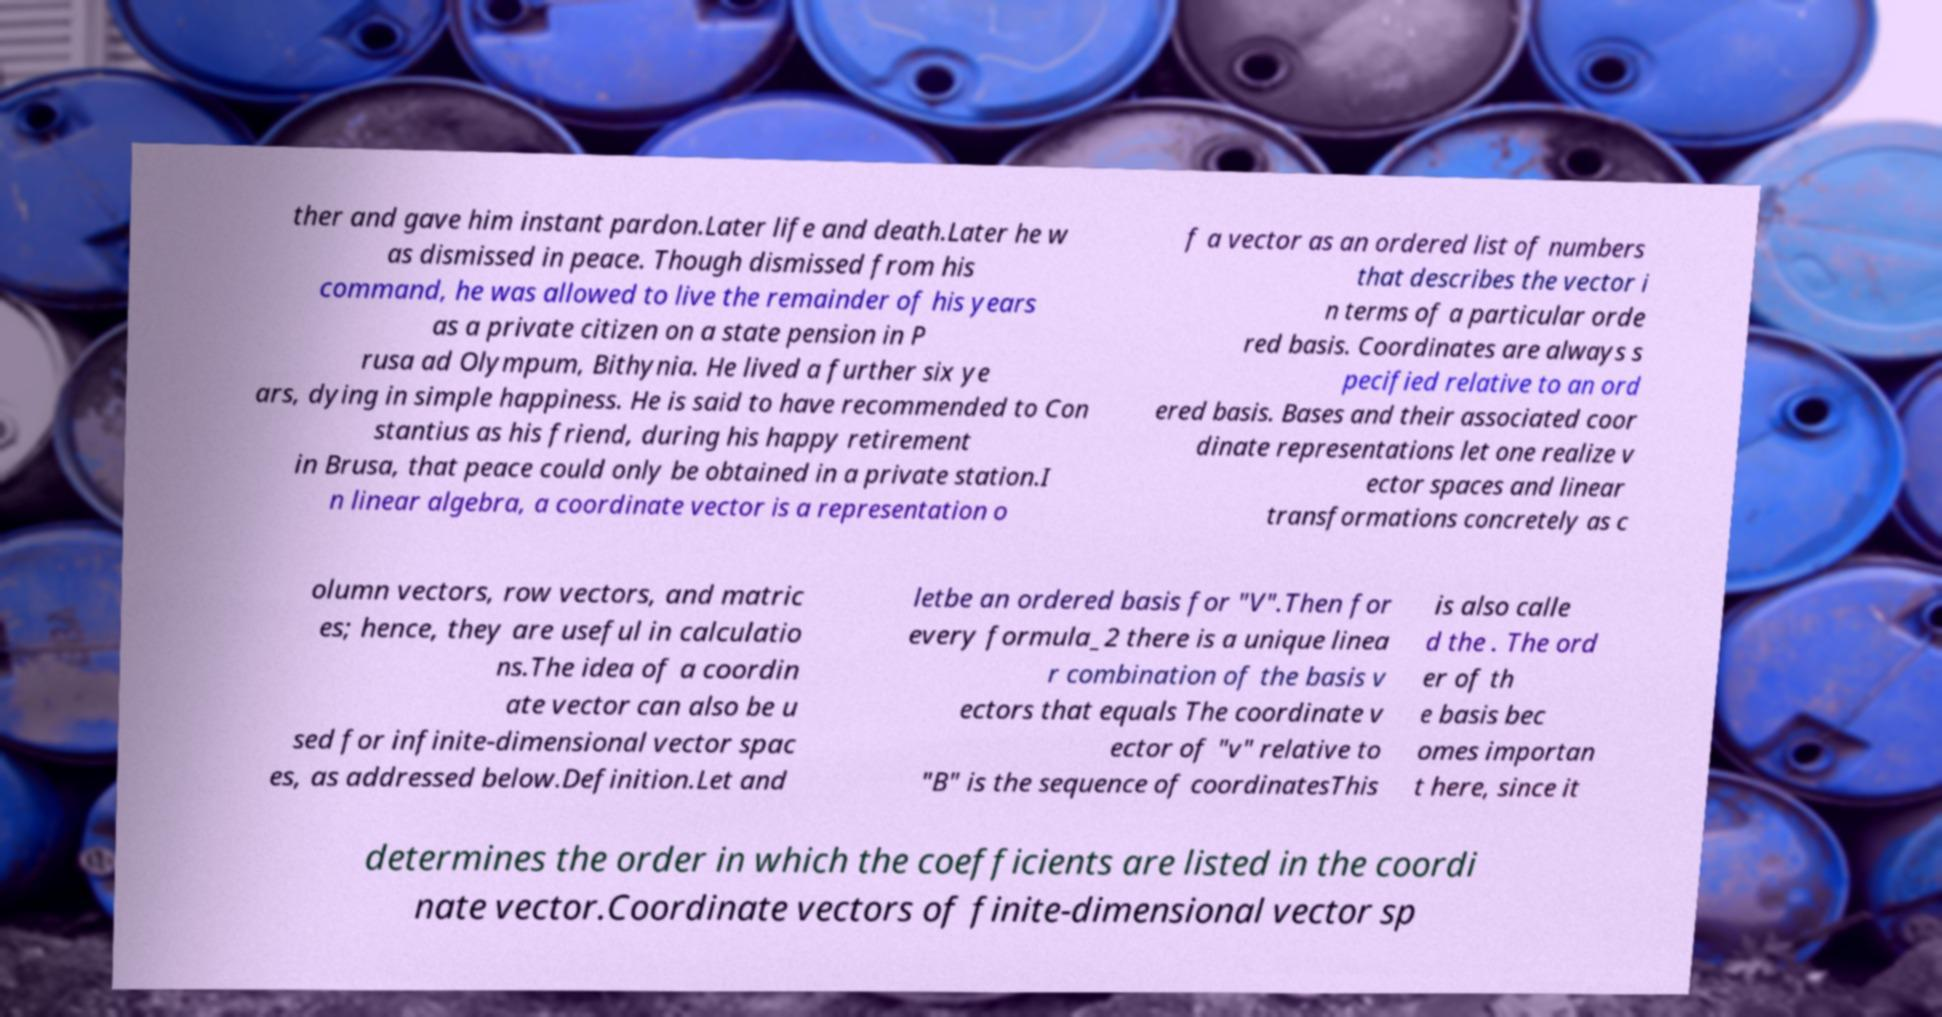Could you extract and type out the text from this image? ther and gave him instant pardon.Later life and death.Later he w as dismissed in peace. Though dismissed from his command, he was allowed to live the remainder of his years as a private citizen on a state pension in P rusa ad Olympum, Bithynia. He lived a further six ye ars, dying in simple happiness. He is said to have recommended to Con stantius as his friend, during his happy retirement in Brusa, that peace could only be obtained in a private station.I n linear algebra, a coordinate vector is a representation o f a vector as an ordered list of numbers that describes the vector i n terms of a particular orde red basis. Coordinates are always s pecified relative to an ord ered basis. Bases and their associated coor dinate representations let one realize v ector spaces and linear transformations concretely as c olumn vectors, row vectors, and matric es; hence, they are useful in calculatio ns.The idea of a coordin ate vector can also be u sed for infinite-dimensional vector spac es, as addressed below.Definition.Let and letbe an ordered basis for "V".Then for every formula_2 there is a unique linea r combination of the basis v ectors that equals The coordinate v ector of "v" relative to "B" is the sequence of coordinatesThis is also calle d the . The ord er of th e basis bec omes importan t here, since it determines the order in which the coefficients are listed in the coordi nate vector.Coordinate vectors of finite-dimensional vector sp 